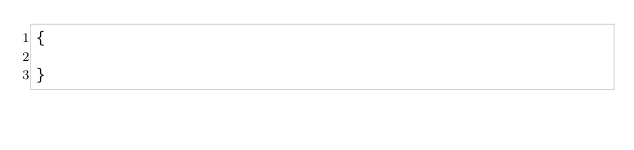<code> <loc_0><loc_0><loc_500><loc_500><_C++_>{

}
</code> 